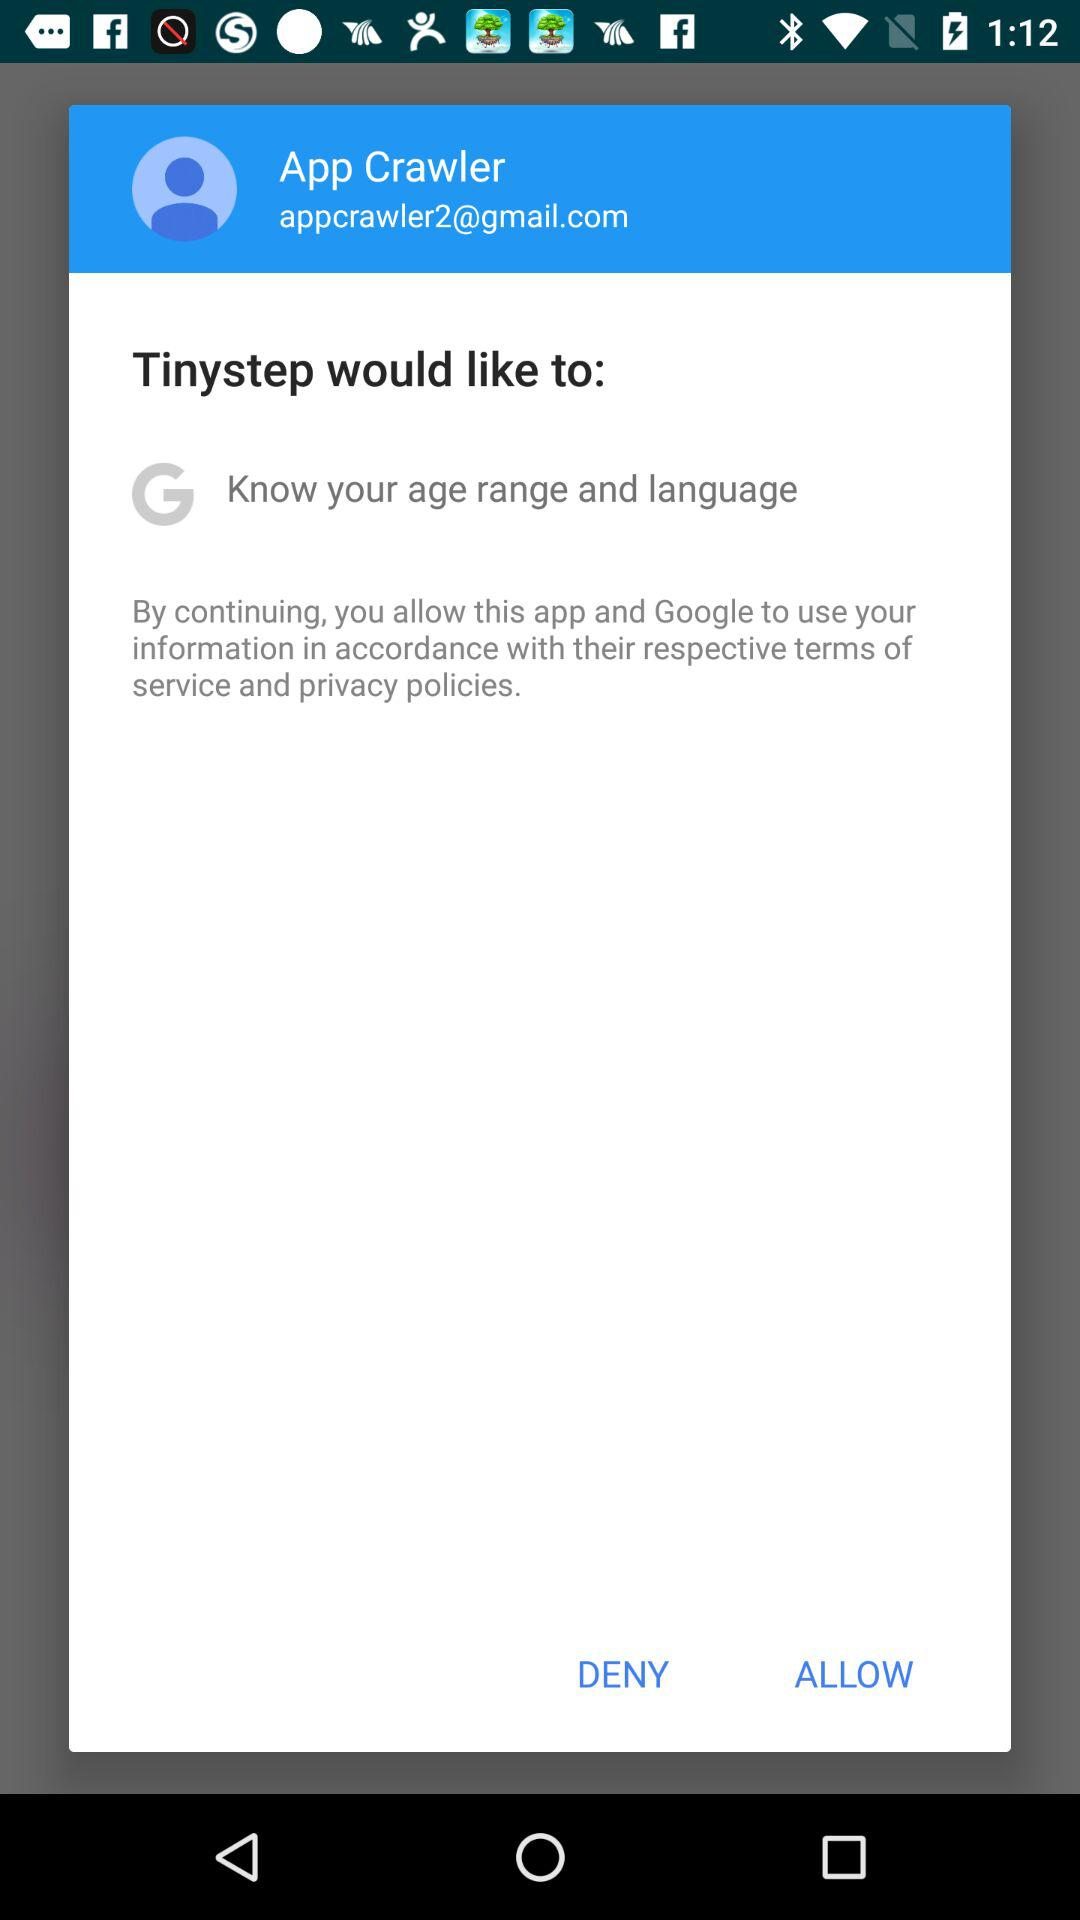What application would like to know my age range and language? The application "Tinystep" would like to know your age range and language. 